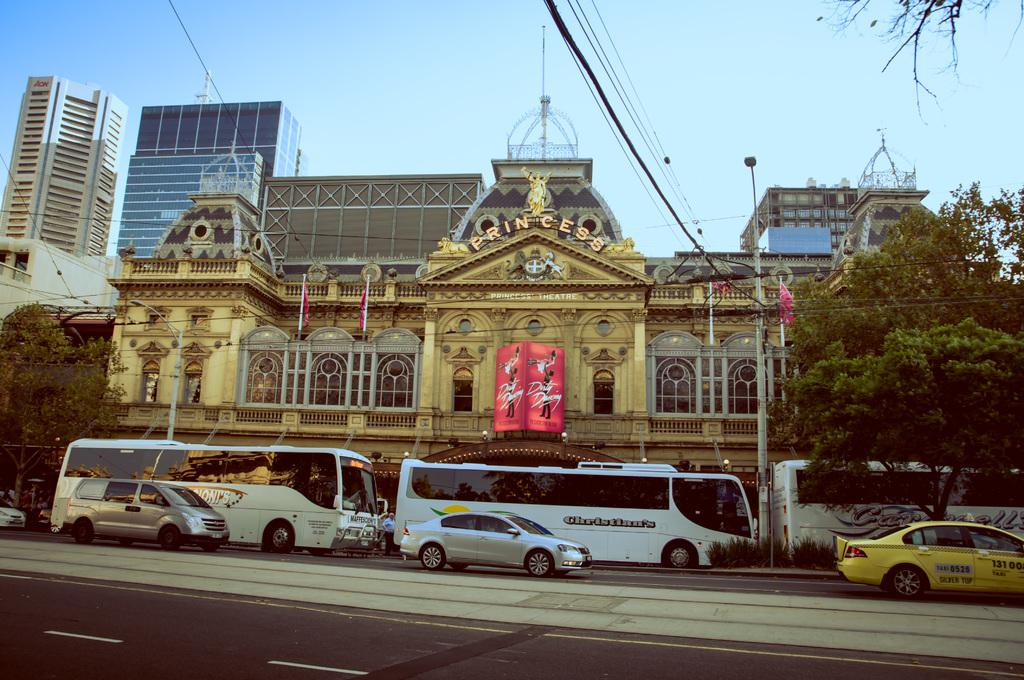<image>
Write a terse but informative summary of the picture. Three white buses sit outside of the Princess Building. 